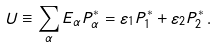<formula> <loc_0><loc_0><loc_500><loc_500>U \equiv \sum _ { \alpha } E _ { \alpha } P _ { \alpha } ^ { * } = \varepsilon _ { 1 } P _ { 1 } ^ { * } + \varepsilon _ { 2 } P _ { 2 } ^ { * } \, .</formula> 